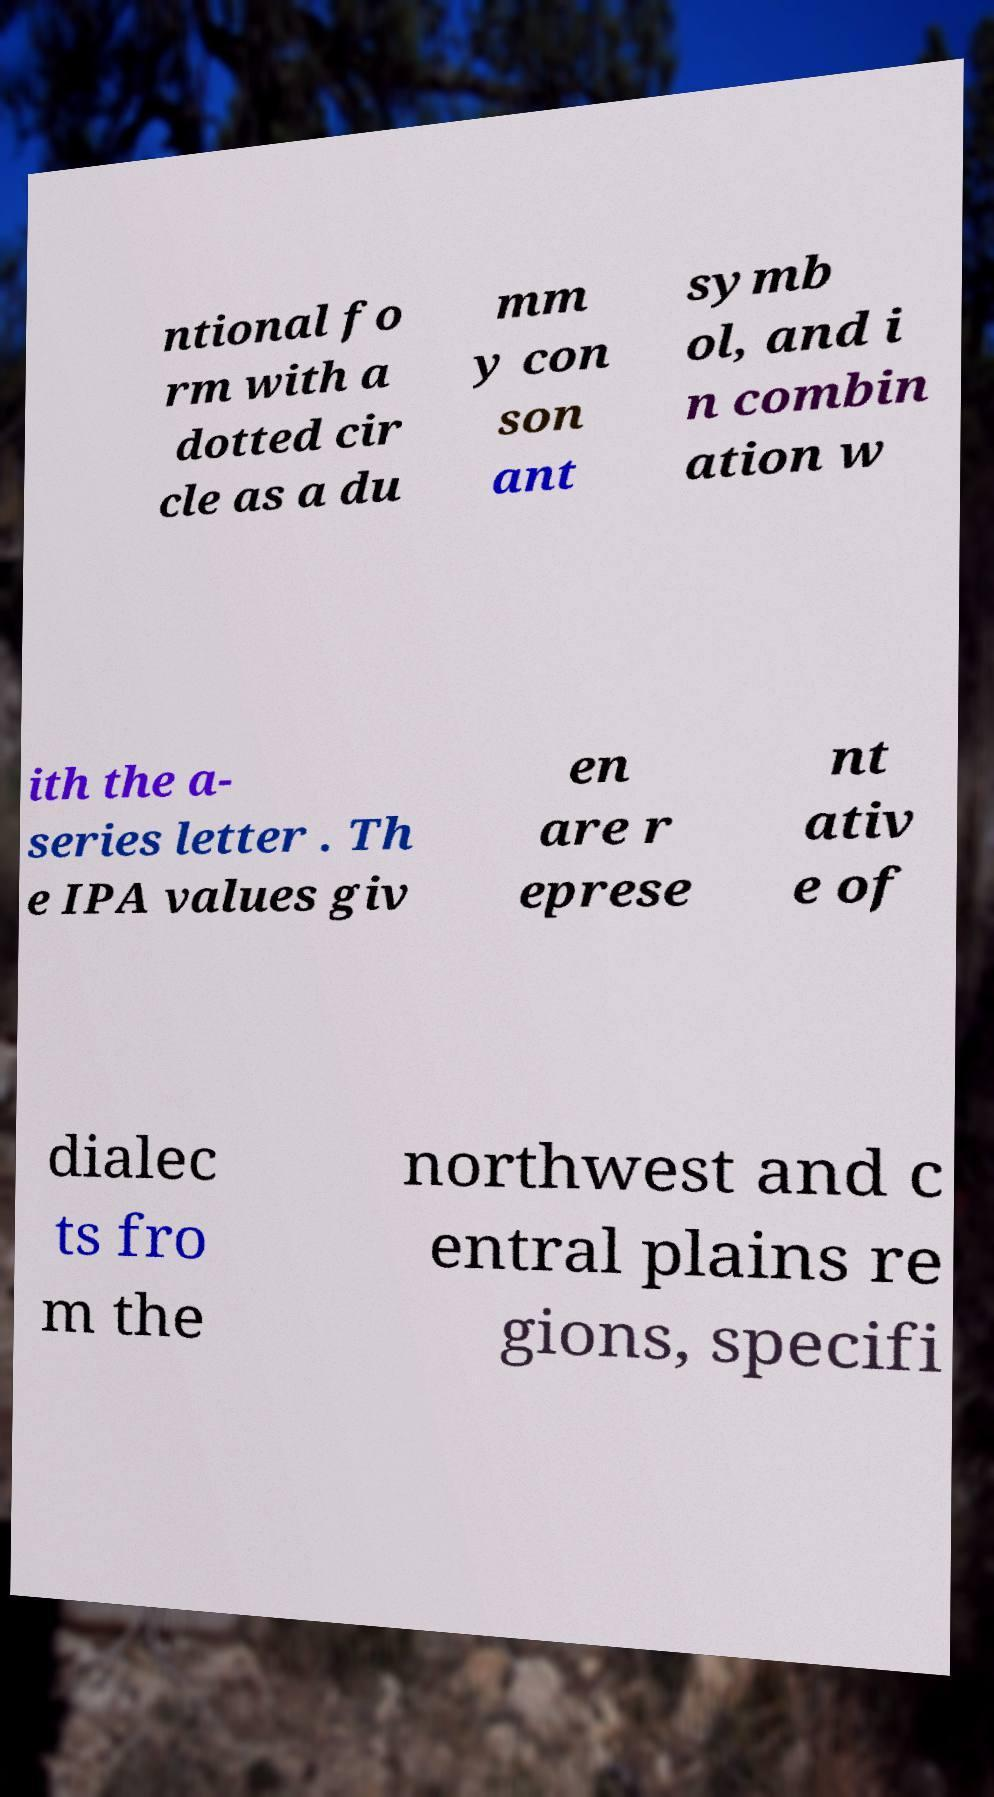Can you read and provide the text displayed in the image?This photo seems to have some interesting text. Can you extract and type it out for me? ntional fo rm with a dotted cir cle as a du mm y con son ant symb ol, and i n combin ation w ith the a- series letter . Th e IPA values giv en are r eprese nt ativ e of dialec ts fro m the northwest and c entral plains re gions, specifi 